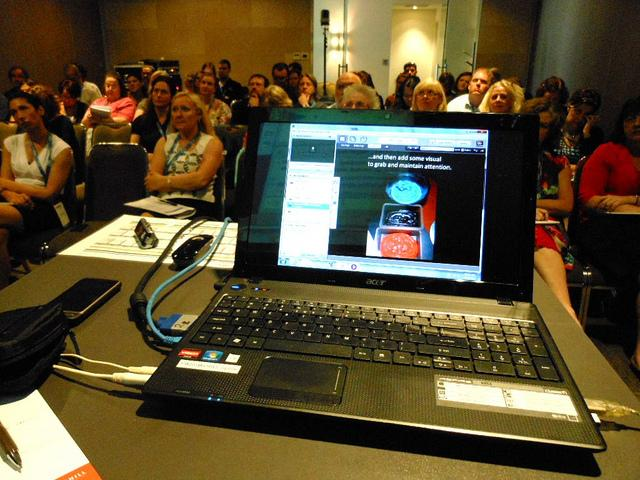What is the purpose of this event? Please explain your reasoning. learn. There is a laptop with a presentation open on it and a group of people sitting listening indicating that something is being taught. 